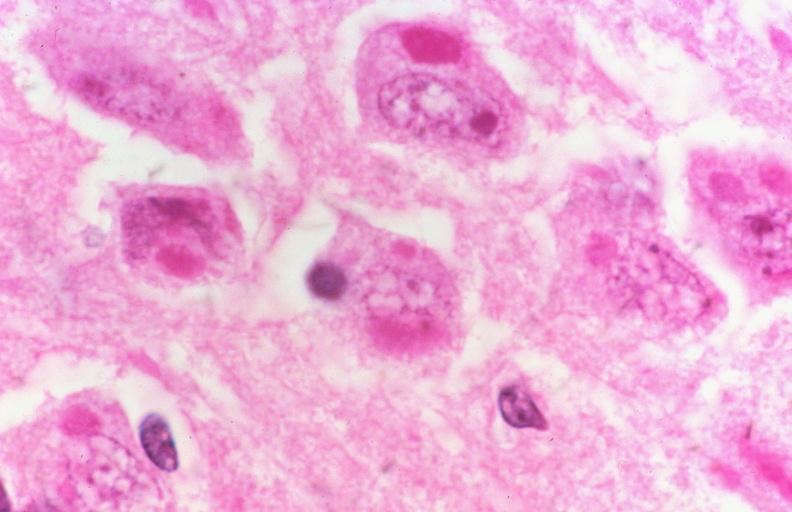s hilar cell tumor present?
Answer the question using a single word or phrase. No 